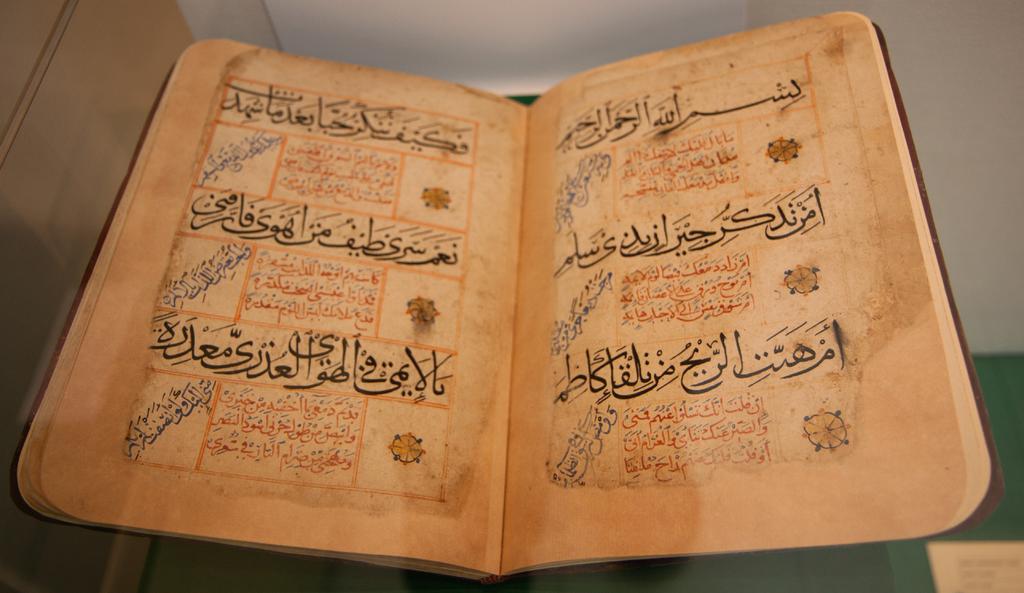All foreign language?
Give a very brief answer. Yes. 